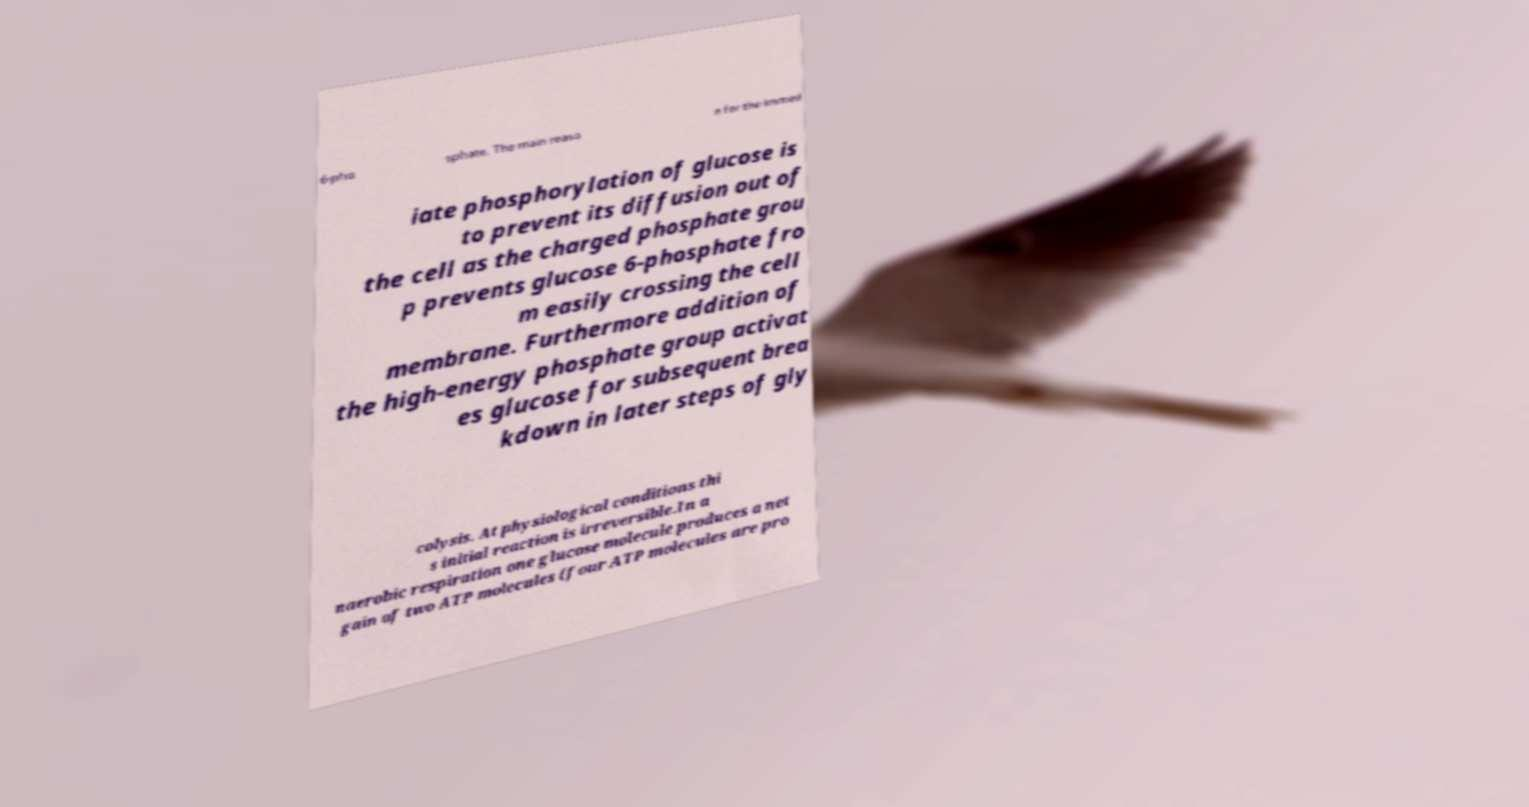Could you extract and type out the text from this image? 6-pho sphate. The main reaso n for the immed iate phosphorylation of glucose is to prevent its diffusion out of the cell as the charged phosphate grou p prevents glucose 6-phosphate fro m easily crossing the cell membrane. Furthermore addition of the high-energy phosphate group activat es glucose for subsequent brea kdown in later steps of gly colysis. At physiological conditions thi s initial reaction is irreversible.In a naerobic respiration one glucose molecule produces a net gain of two ATP molecules (four ATP molecules are pro 